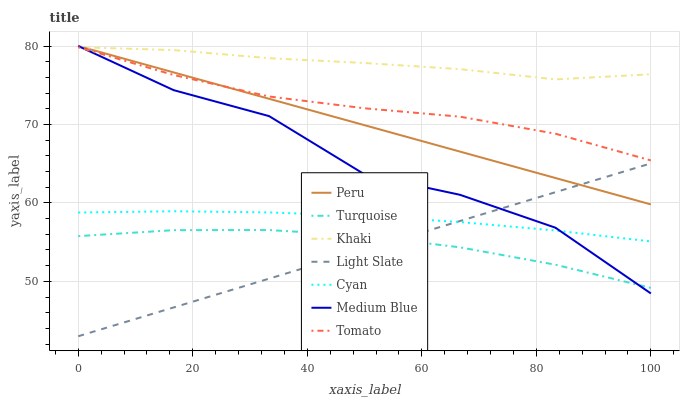Does Light Slate have the minimum area under the curve?
Answer yes or no. Yes. Does Khaki have the maximum area under the curve?
Answer yes or no. Yes. Does Turquoise have the minimum area under the curve?
Answer yes or no. No. Does Turquoise have the maximum area under the curve?
Answer yes or no. No. Is Peru the smoothest?
Answer yes or no. Yes. Is Medium Blue the roughest?
Answer yes or no. Yes. Is Turquoise the smoothest?
Answer yes or no. No. Is Turquoise the roughest?
Answer yes or no. No. Does Light Slate have the lowest value?
Answer yes or no. Yes. Does Turquoise have the lowest value?
Answer yes or no. No. Does Peru have the highest value?
Answer yes or no. Yes. Does Khaki have the highest value?
Answer yes or no. No. Is Cyan less than Khaki?
Answer yes or no. Yes. Is Peru greater than Cyan?
Answer yes or no. Yes. Does Khaki intersect Peru?
Answer yes or no. Yes. Is Khaki less than Peru?
Answer yes or no. No. Is Khaki greater than Peru?
Answer yes or no. No. Does Cyan intersect Khaki?
Answer yes or no. No. 